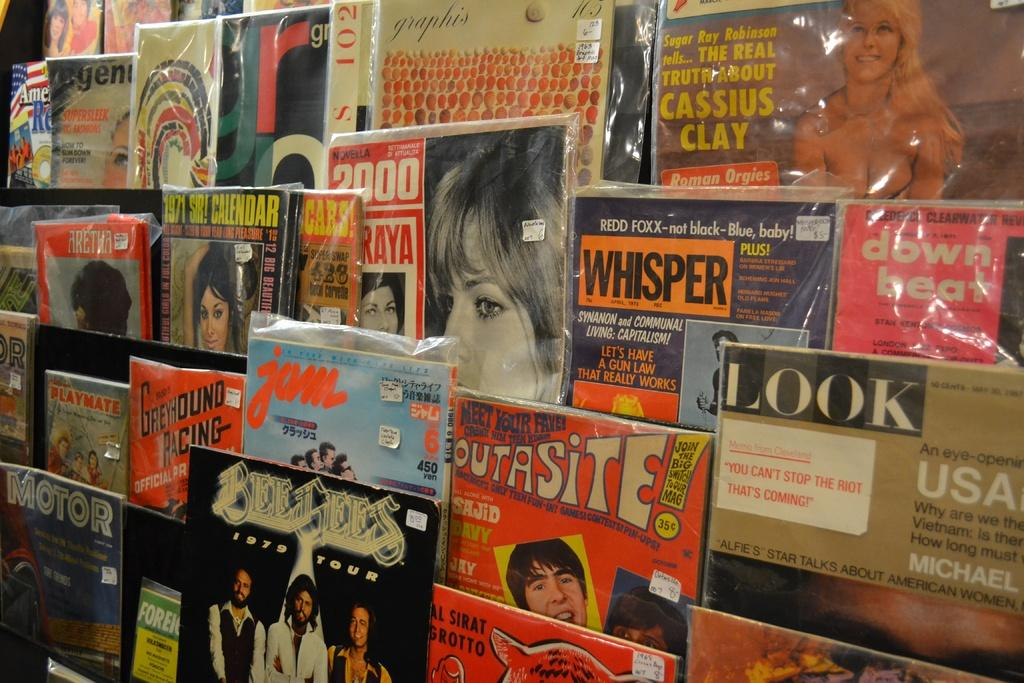Provide a one-sentence caption for the provided image. Greyhound Racing Magazine and Look Magazine from the USA>. 